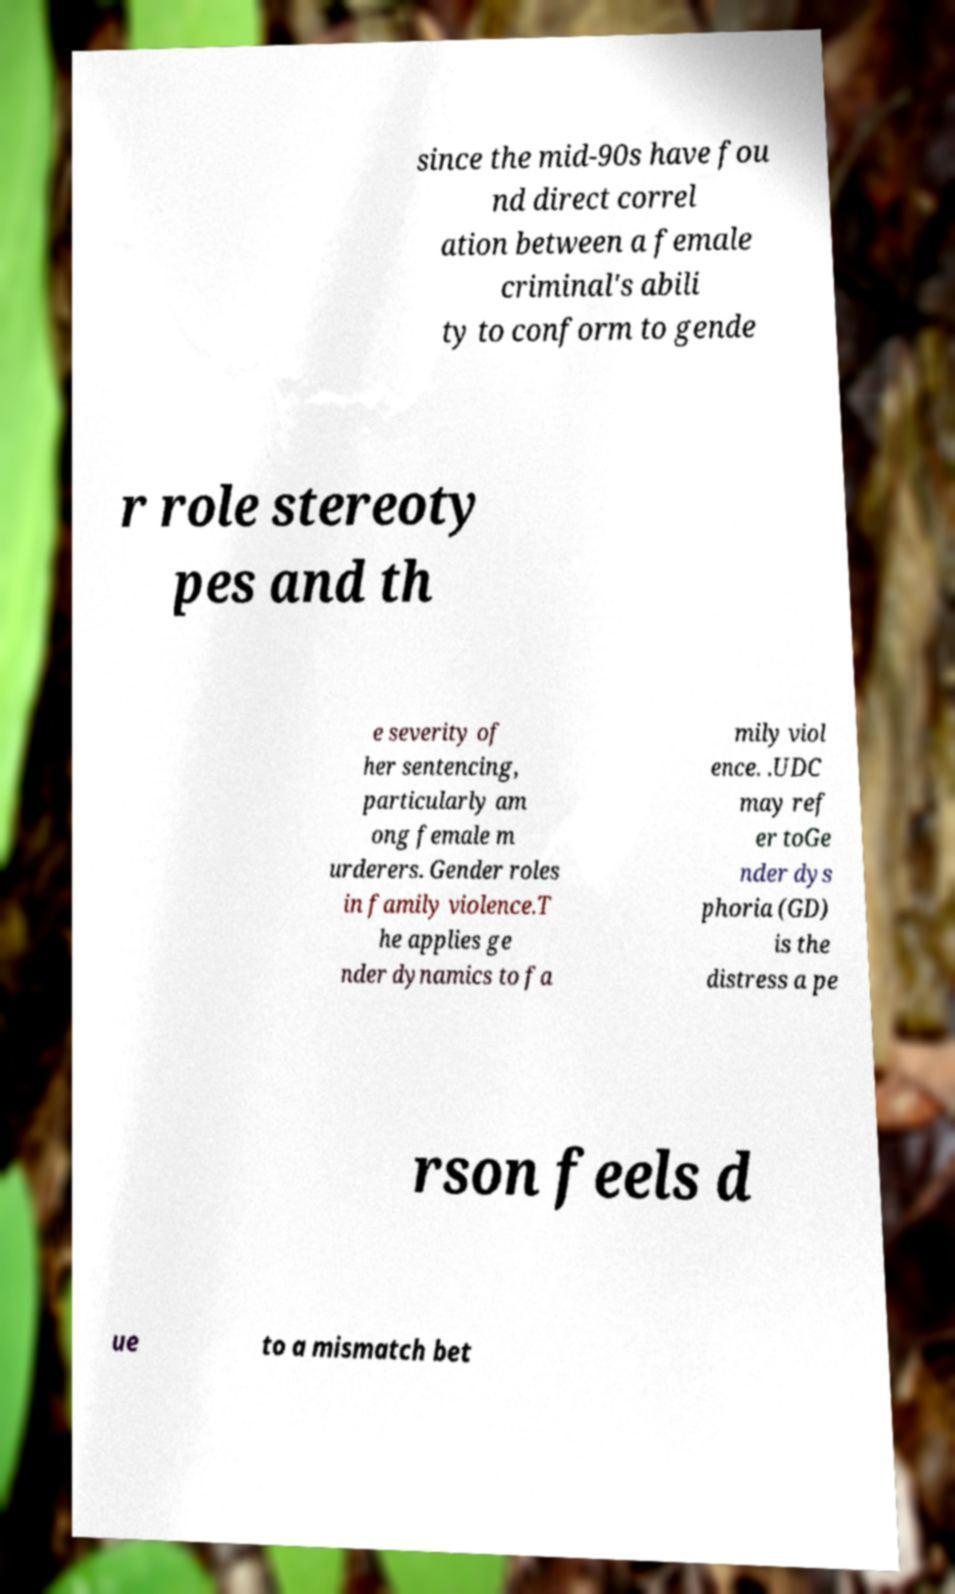Please read and relay the text visible in this image. What does it say? since the mid-90s have fou nd direct correl ation between a female criminal's abili ty to conform to gende r role stereoty pes and th e severity of her sentencing, particularly am ong female m urderers. Gender roles in family violence.T he applies ge nder dynamics to fa mily viol ence. .UDC may ref er toGe nder dys phoria (GD) is the distress a pe rson feels d ue to a mismatch bet 